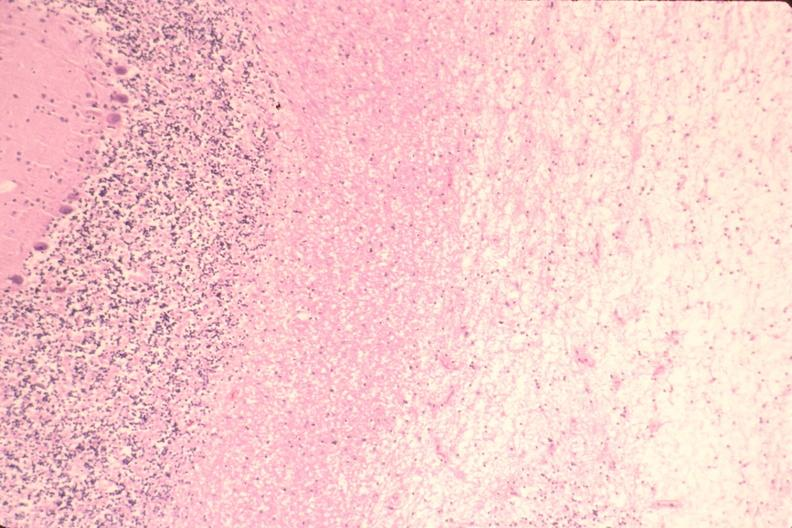does this image show brain, encephalomalasia?
Answer the question using a single word or phrase. Yes 